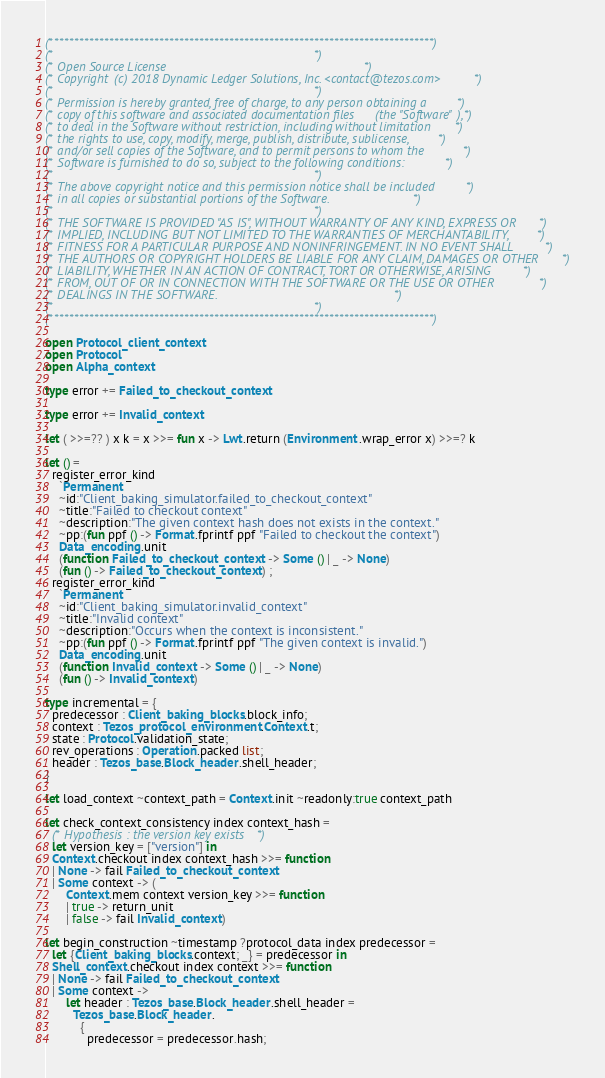Convert code to text. <code><loc_0><loc_0><loc_500><loc_500><_OCaml_>(*****************************************************************************)
(*                                                                           *)
(* Open Source License                                                       *)
(* Copyright (c) 2018 Dynamic Ledger Solutions, Inc. <contact@tezos.com>     *)
(*                                                                           *)
(* Permission is hereby granted, free of charge, to any person obtaining a   *)
(* copy of this software and associated documentation files (the "Software"),*)
(* to deal in the Software without restriction, including without limitation *)
(* the rights to use, copy, modify, merge, publish, distribute, sublicense,  *)
(* and/or sell copies of the Software, and to permit persons to whom the     *)
(* Software is furnished to do so, subject to the following conditions:      *)
(*                                                                           *)
(* The above copyright notice and this permission notice shall be included   *)
(* in all copies or substantial portions of the Software.                    *)
(*                                                                           *)
(* THE SOFTWARE IS PROVIDED "AS IS", WITHOUT WARRANTY OF ANY KIND, EXPRESS OR*)
(* IMPLIED, INCLUDING BUT NOT LIMITED TO THE WARRANTIES OF MERCHANTABILITY,  *)
(* FITNESS FOR A PARTICULAR PURPOSE AND NONINFRINGEMENT. IN NO EVENT SHALL   *)
(* THE AUTHORS OR COPYRIGHT HOLDERS BE LIABLE FOR ANY CLAIM, DAMAGES OR OTHER*)
(* LIABILITY, WHETHER IN AN ACTION OF CONTRACT, TORT OR OTHERWISE, ARISING   *)
(* FROM, OUT OF OR IN CONNECTION WITH THE SOFTWARE OR THE USE OR OTHER       *)
(* DEALINGS IN THE SOFTWARE.                                                 *)
(*                                                                           *)
(*****************************************************************************)

open Protocol_client_context
open Protocol
open Alpha_context

type error += Failed_to_checkout_context

type error += Invalid_context

let ( >>=?? ) x k = x >>= fun x -> Lwt.return (Environment.wrap_error x) >>=? k

let () =
  register_error_kind
    `Permanent
    ~id:"Client_baking_simulator.failed_to_checkout_context"
    ~title:"Failed to checkout context"
    ~description:"The given context hash does not exists in the context."
    ~pp:(fun ppf () -> Format.fprintf ppf "Failed to checkout the context")
    Data_encoding.unit
    (function Failed_to_checkout_context -> Some () | _ -> None)
    (fun () -> Failed_to_checkout_context) ;
  register_error_kind
    `Permanent
    ~id:"Client_baking_simulator.invalid_context"
    ~title:"Invalid context"
    ~description:"Occurs when the context is inconsistent."
    ~pp:(fun ppf () -> Format.fprintf ppf "The given context is invalid.")
    Data_encoding.unit
    (function Invalid_context -> Some () | _ -> None)
    (fun () -> Invalid_context)

type incremental = {
  predecessor : Client_baking_blocks.block_info;
  context : Tezos_protocol_environment.Context.t;
  state : Protocol.validation_state;
  rev_operations : Operation.packed list;
  header : Tezos_base.Block_header.shell_header;
}

let load_context ~context_path = Context.init ~readonly:true context_path

let check_context_consistency index context_hash =
  (* Hypothesis : the version key exists *)
  let version_key = ["version"] in
  Context.checkout index context_hash >>= function
  | None -> fail Failed_to_checkout_context
  | Some context -> (
      Context.mem context version_key >>= function
      | true -> return_unit
      | false -> fail Invalid_context)

let begin_construction ~timestamp ?protocol_data index predecessor =
  let {Client_baking_blocks.context; _} = predecessor in
  Shell_context.checkout index context >>= function
  | None -> fail Failed_to_checkout_context
  | Some context ->
      let header : Tezos_base.Block_header.shell_header =
        Tezos_base.Block_header.
          {
            predecessor = predecessor.hash;</code> 